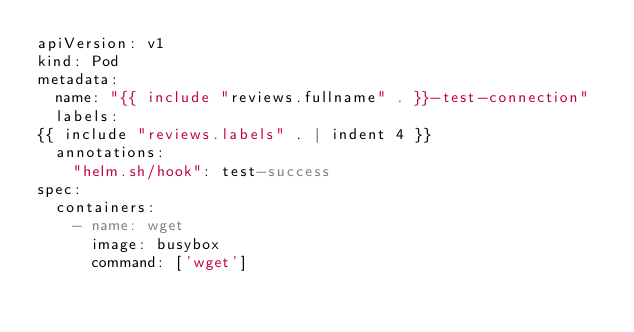<code> <loc_0><loc_0><loc_500><loc_500><_YAML_>apiVersion: v1
kind: Pod
metadata:
  name: "{{ include "reviews.fullname" . }}-test-connection"
  labels:
{{ include "reviews.labels" . | indent 4 }}
  annotations:
    "helm.sh/hook": test-success
spec:
  containers:
    - name: wget
      image: busybox
      command: ['wget']</code> 